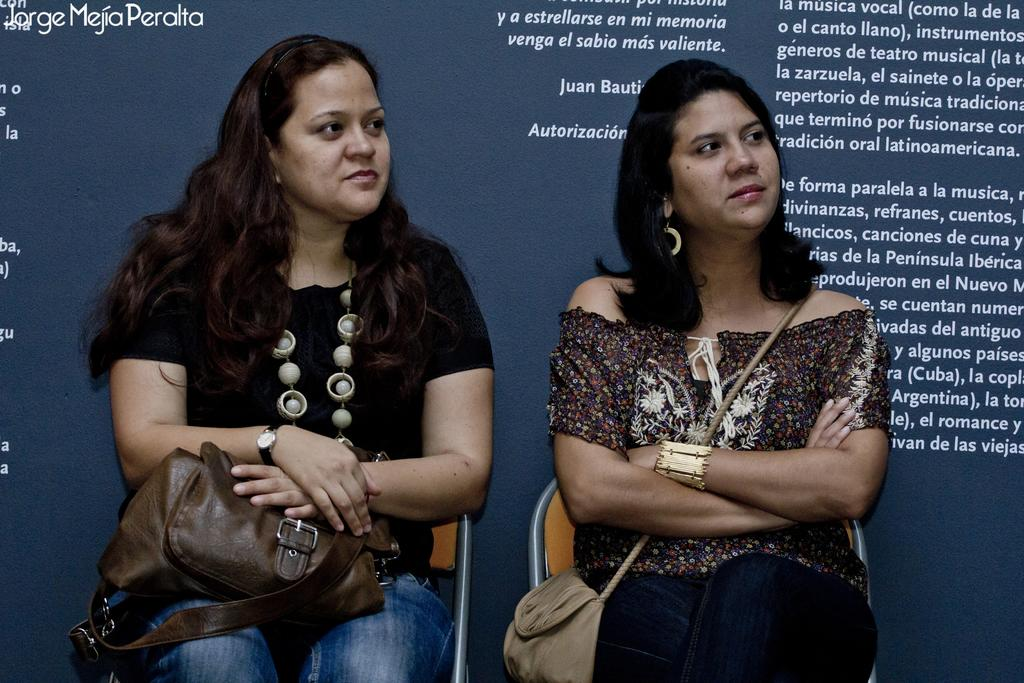How many women are in the foreground of the picture? There are two women in the foreground of the picture. What are the women doing in the image? The women are sitting in chairs. What can be seen in the background of the picture? There is a banner in the background of the picture. What is written on the banner? There is text on the banner. What types of pets are visible in the image? There are no pets visible in the image. What occasion is being celebrated in the image? The image does not depict a specific occasion or celebration. 